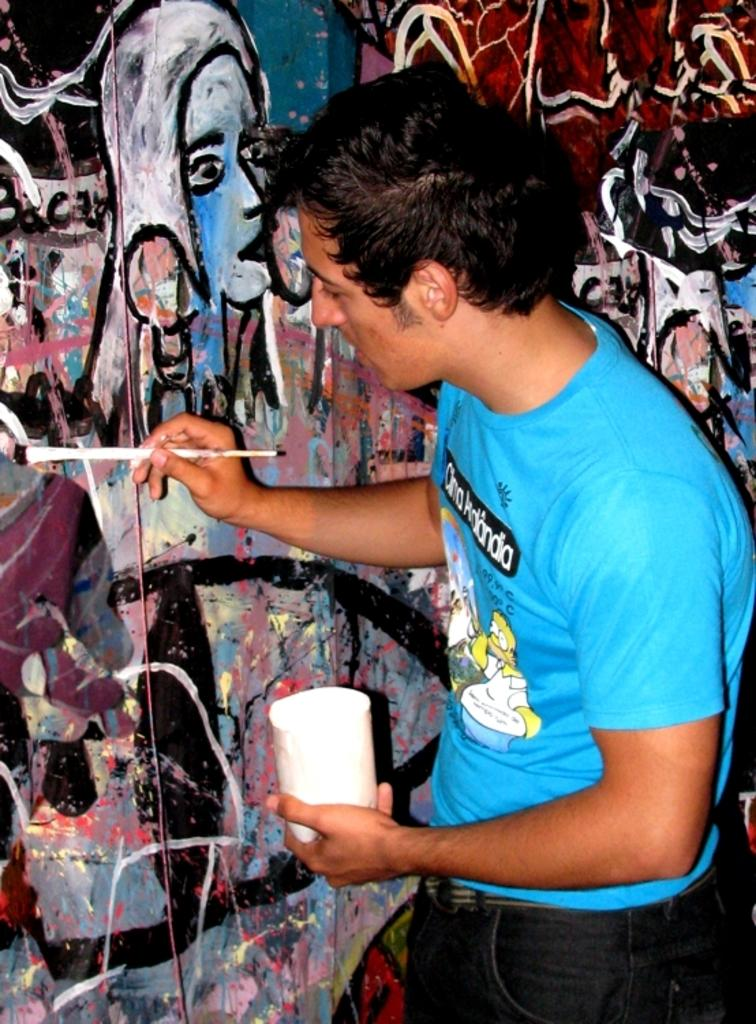What is the main subject of the image? There is a person in the image. What is the person doing in the image? The person is standing and painting on a wall. What tools is the person using for painting? The person is holding a paint brush and a glass. What type of yak can be seen in the image? There is no yak present in the image; it features a person painting on a wall. How does the person's painting relate to the concept of death in the image? The image does not depict any connection to the concept of death; it simply shows a person painting on a wall. 